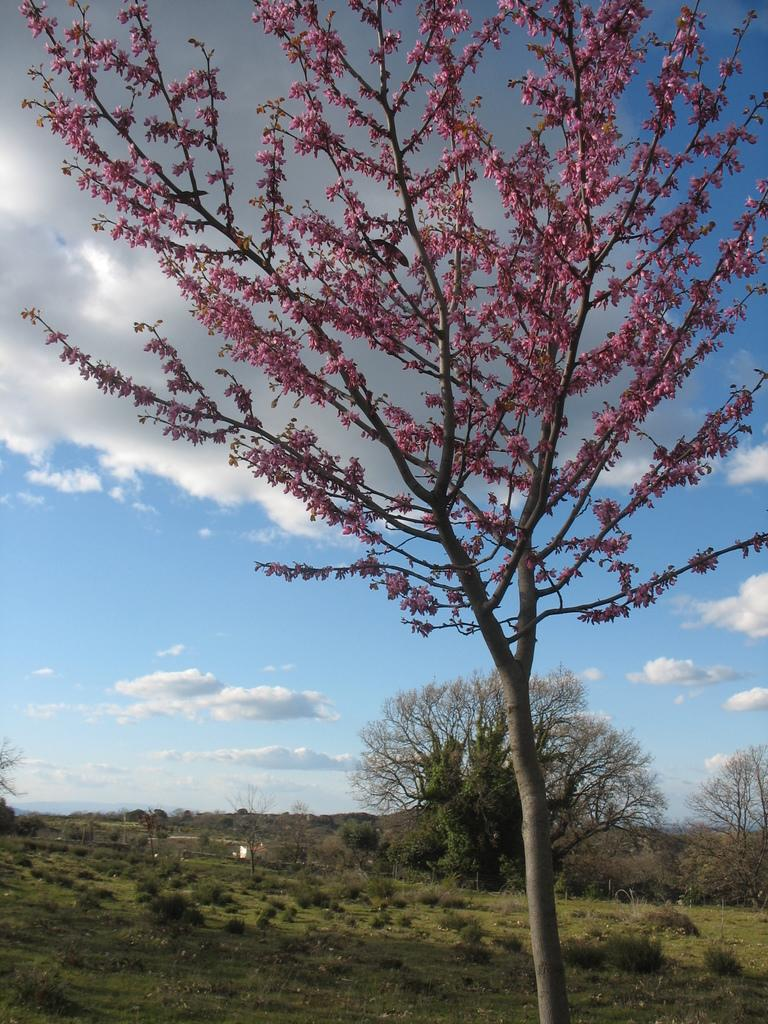What type of vegetation can be seen in the foreground of the image? There are flowers on the branches of a tree in the foreground of the image. What can be seen in the background of the image? There is a group of trees in the background of the image. What is the condition of the sky in the image? The sky is cloudy and visible in the background of the image. What type of love event is taking place in the mine in the image? There is no mention of a love event or a mine in the image; it features a tree with flowers in the foreground and a group of trees in the background with a cloudy sky. 